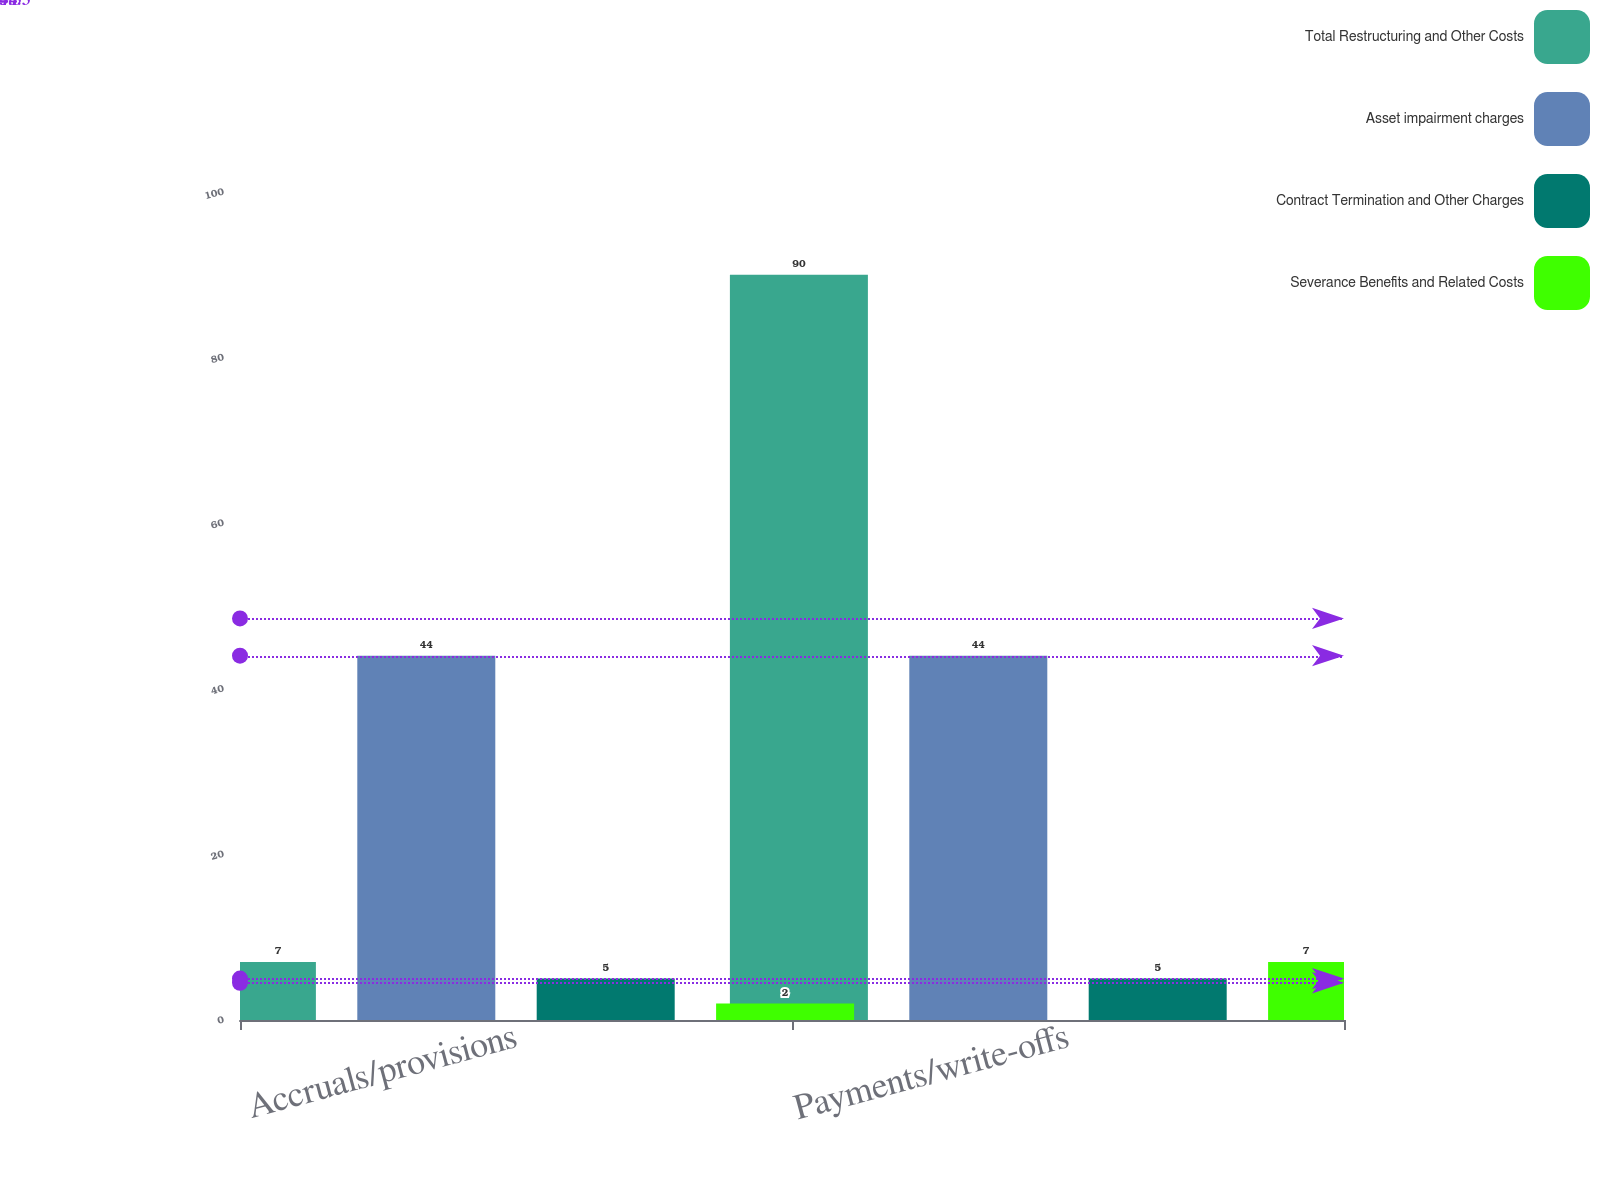<chart> <loc_0><loc_0><loc_500><loc_500><stacked_bar_chart><ecel><fcel>Accruals/provisions<fcel>Payments/write-offs<nl><fcel>Total Restructuring and Other Costs<fcel>7<fcel>90<nl><fcel>Asset impairment charges<fcel>44<fcel>44<nl><fcel>Contract Termination and Other Charges<fcel>5<fcel>5<nl><fcel>Severance Benefits and Related Costs<fcel>2<fcel>7<nl></chart> 